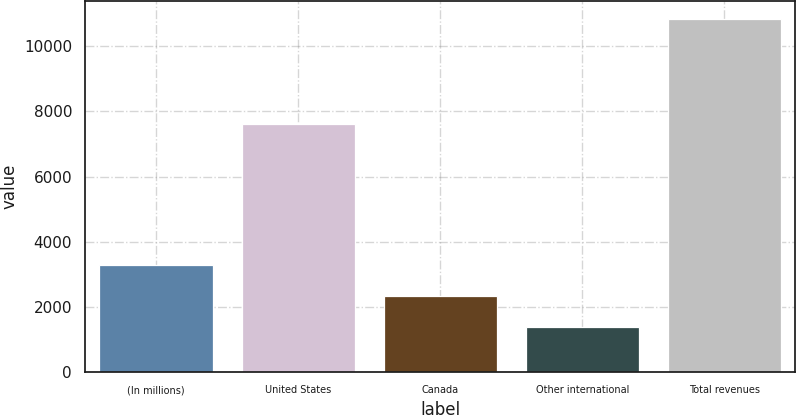Convert chart to OTSL. <chart><loc_0><loc_0><loc_500><loc_500><bar_chart><fcel>(In millions)<fcel>United States<fcel>Canada<fcel>Other international<fcel>Total revenues<nl><fcel>3277.2<fcel>7609<fcel>2331.1<fcel>1385<fcel>10846<nl></chart> 